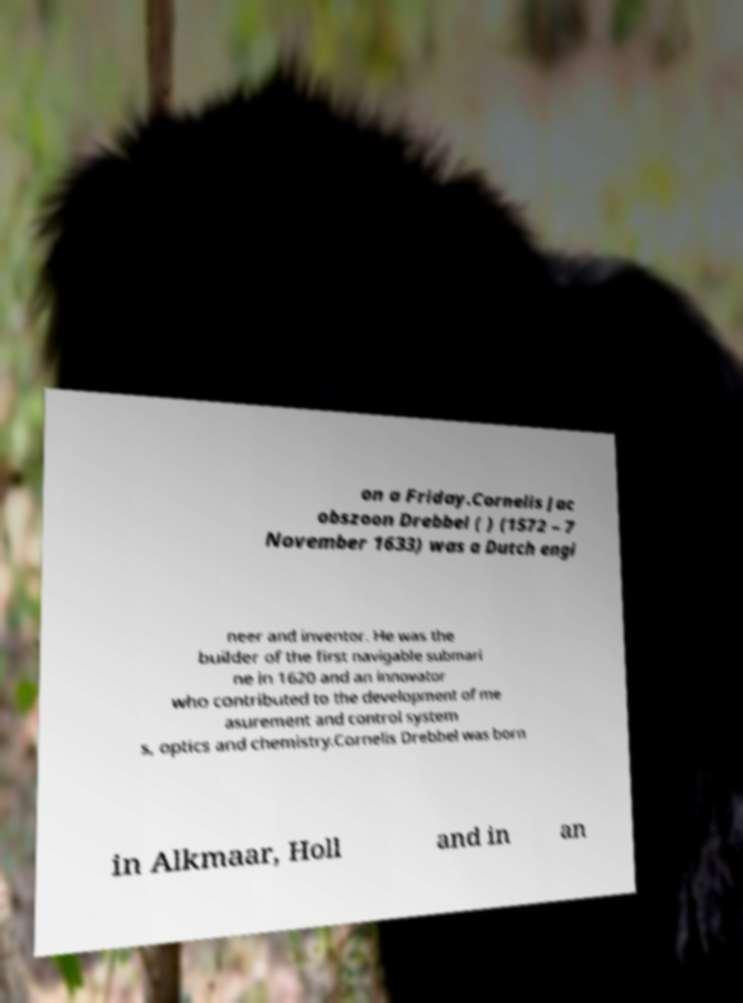Please identify and transcribe the text found in this image. on a Friday.Cornelis Jac obszoon Drebbel ( ) (1572 – 7 November 1633) was a Dutch engi neer and inventor. He was the builder of the first navigable submari ne in 1620 and an innovator who contributed to the development of me asurement and control system s, optics and chemistry.Cornelis Drebbel was born in Alkmaar, Holl and in an 